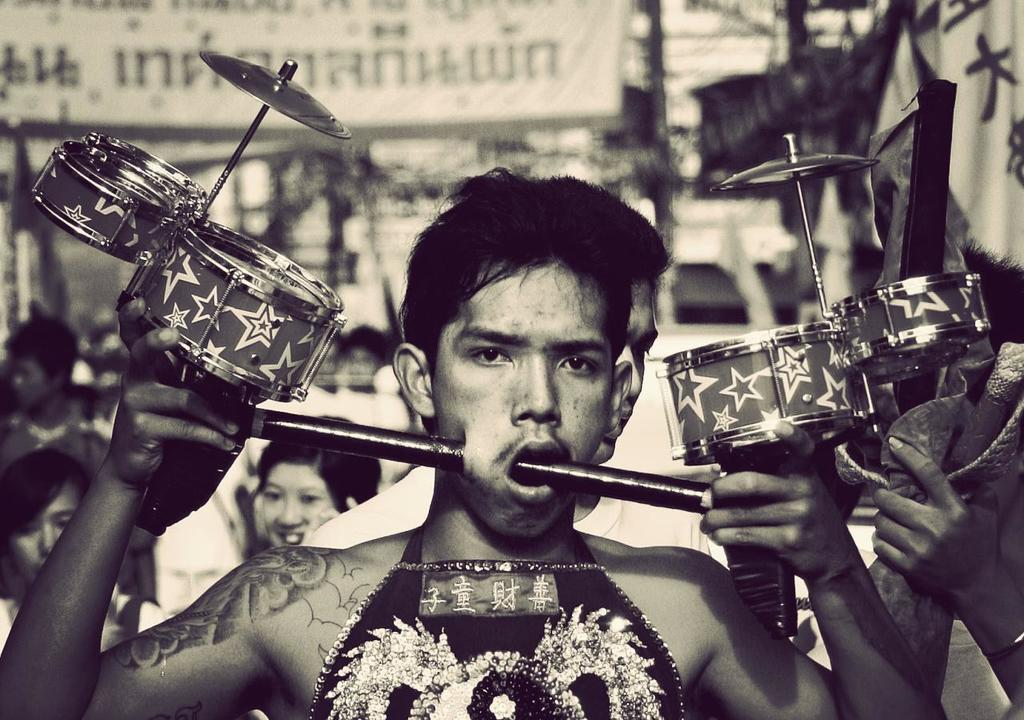What is the color scheme of the image? The image is black and white. What is the person in the foreground of the image doing? The person is holding a musical instrument in the image. Can you describe the people behind the person with the musical instrument? There are other people visible behind the person with the musical instrument. What type of brush is being used to play the musical instrument in the image? There is no brush visible in the image, and the person is not using a brush to play the musical instrument. 